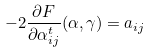Convert formula to latex. <formula><loc_0><loc_0><loc_500><loc_500>- 2 \frac { \partial F } { \partial \alpha ^ { t } _ { i j } } ( \alpha , \gamma ) = a _ { i j }</formula> 